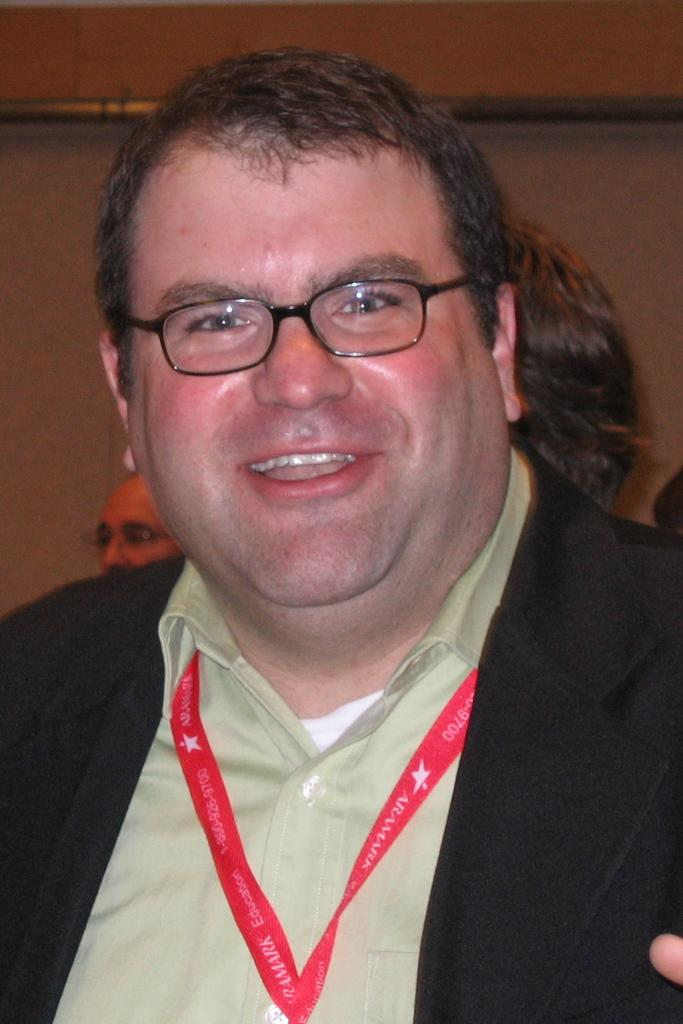Who is present in the image? There is a man in the image. What is the man doing in the image? The man is smiling in the image. What accessory is the man wearing? The man is wearing spectacles in the image. What can be seen in the background of the image? There are people and a wall in the background of the image. What type of book is the cow reading in the image? There is no cow or book present in the image. 